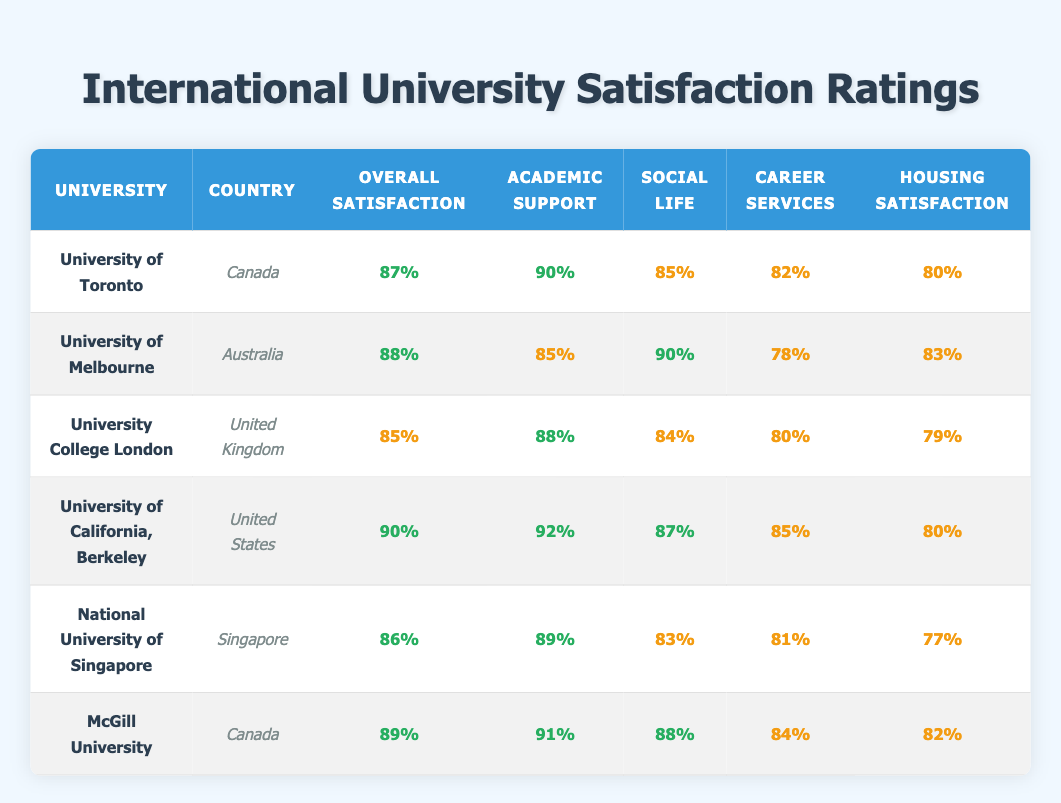What is the overall satisfaction rating for the University of California, Berkeley? The table shows that the overall satisfaction rating for the University of California, Berkeley is listed as 90%.
Answer: 90% Which university has the highest academic support rating? By comparing the academic support ratings in the table, the University of California, Berkeley has the highest rating at 92%.
Answer: University of California, Berkeley What is the average housing satisfaction rating for all listed universities? To find the average, I will sum the housing satisfaction ratings (80 + 83 + 79 + 80 + 77 + 82 = 481) and then divide by the number of universities (481/6 = 80.17). So, the average is approximately 80.17%.
Answer: 80.17% Is the social life satisfaction of the University of Melbourne higher than that of the National University of Singapore? The social life satisfaction for the University of Melbourne is 90%, whereas for the National University of Singapore it is 83%. Since 90% is greater than 83%, the statement is true.
Answer: Yes Which university has the lowest overall satisfaction rating, and what is that rating? By examining the overall satisfaction ratings across all universities, the University College London has the lowest rating at 85%.
Answer: University College London, 85% What is the difference in career services ratings between McGill University and University of Toronto? From the table, McGill University's career services rating is 84% and the University of Toronto's is 82%. The difference is calculated by subtracting (84 - 82 = 2).
Answer: 2% Which university has the highest rating for social life and what is that rating? The table shows the social life ratings, with the University of Melbourne having the highest rating at 90%.
Answer: University of Melbourne, 90% Is academic support at McGill University rated higher than academic support at the University College London? The table indicates that McGill University has an academic support rating of 91%, while University College London has a rating of 88%. Therefore, the statement is true since 91% is greater than 88%.
Answer: Yes 